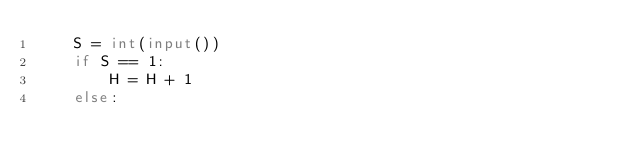Convert code to text. <code><loc_0><loc_0><loc_500><loc_500><_Python_>    S = int(input())
    if S == 1:
        H = H + 1
    else:</code> 